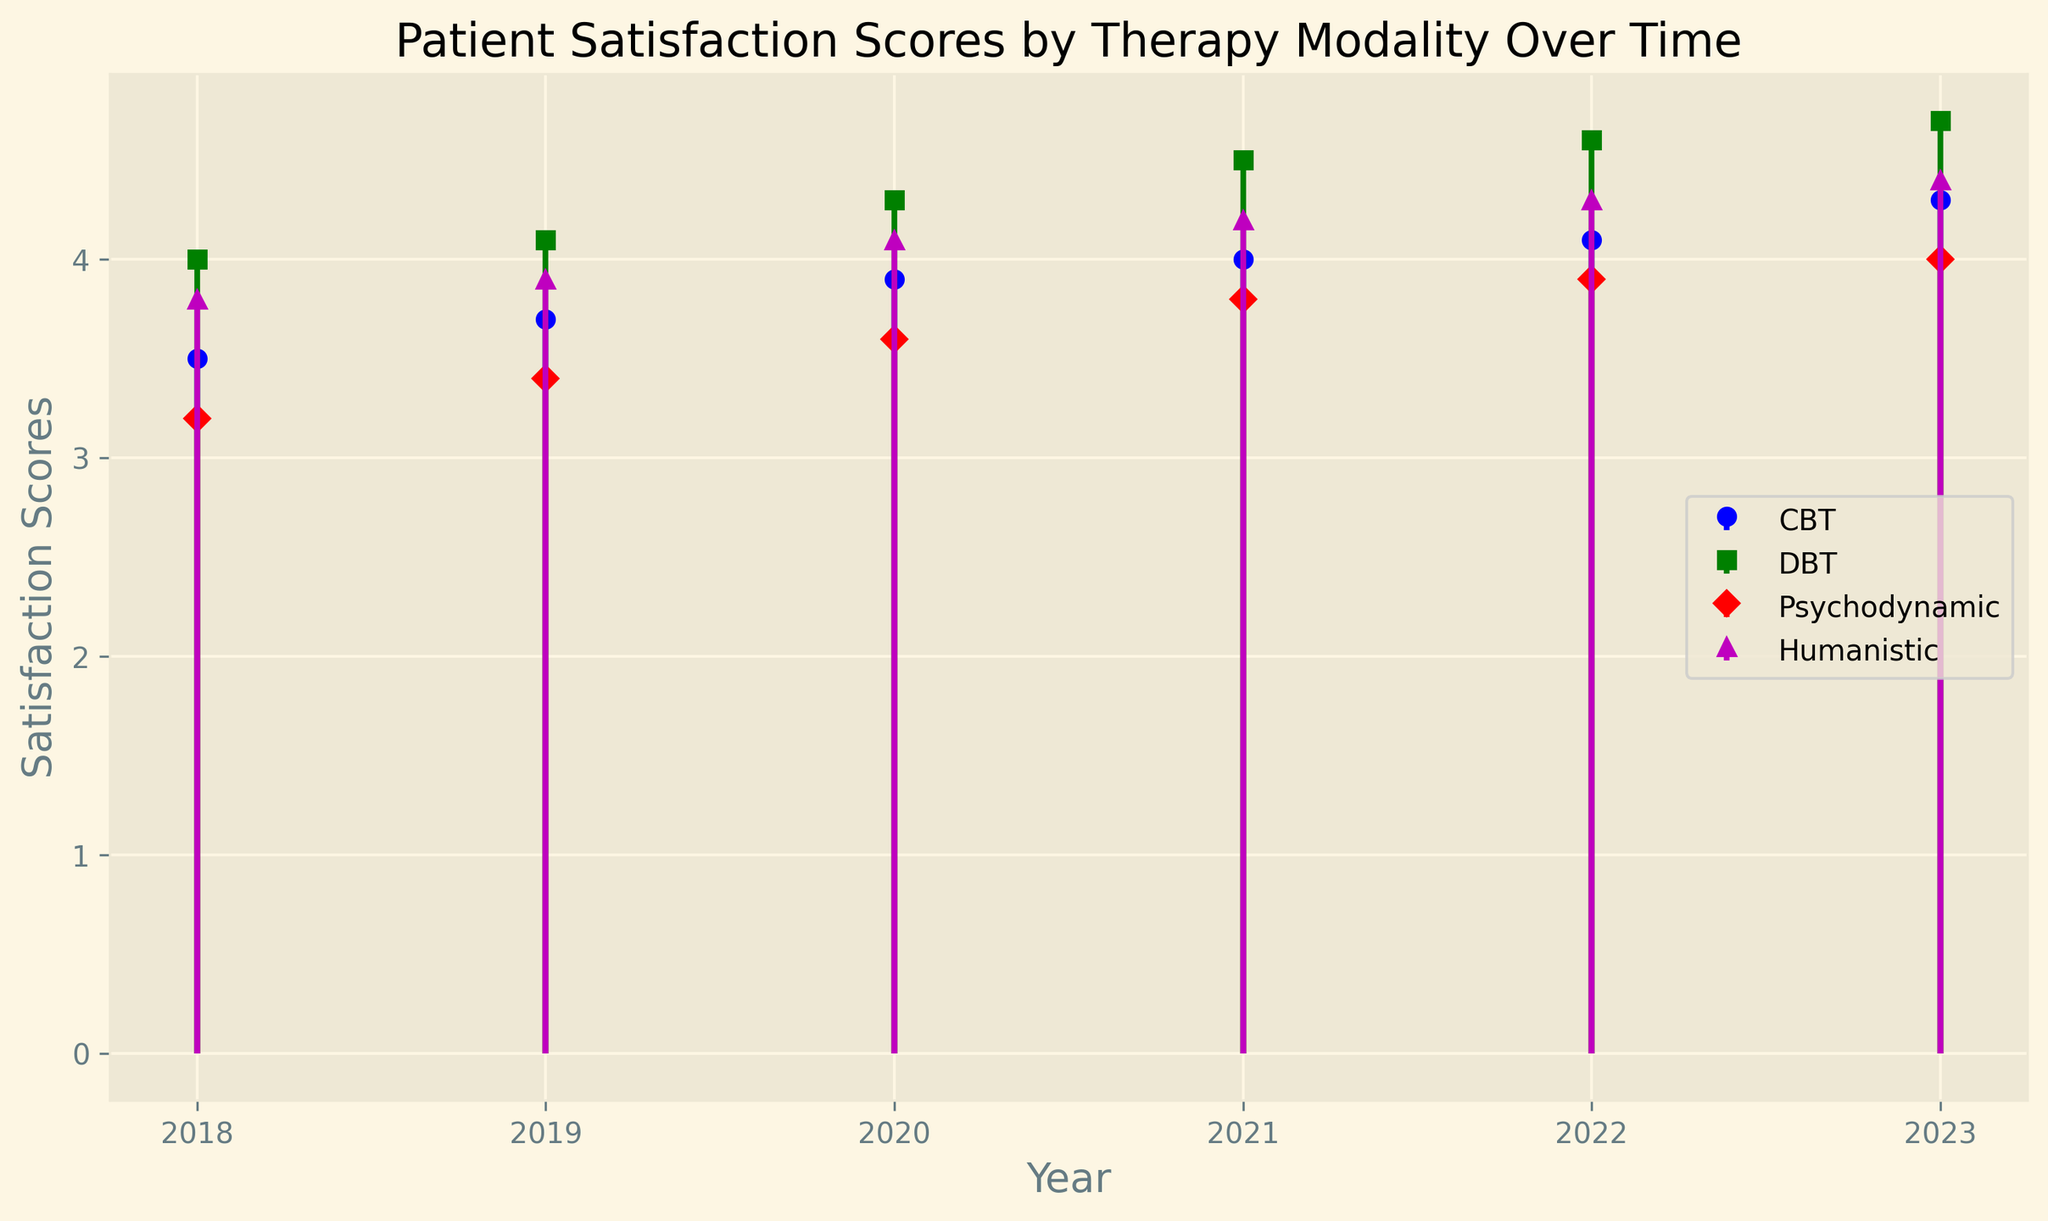What's the highest satisfaction score for CBT and in which year was it achieved? Look at the stem for CBT, identify the highest point, which is 4.3 in 2023.
Answer: 4.3 in 2023 How did the satisfaction score for Humanistic therapy change from 2018 to 2023? Compare the satisfaction score for Humanistic therapy in 2018 (3.8) and 2023 (4.4). Calculate the difference which is 4.4 - 3.8 = 0.6.
Answer: Increased by 0.6 Which therapy modality showed the greatest increase in satisfaction scores from 2018 to 2023? Calculate the increase for each modality: CBT (4.3 - 3.5 = 0.8), DBT (4.7 - 4.0 = 0.7), Psychodynamic (4.0 - 3.2 = 0.8), Humanistic (4.4 - 3.8 = 0.6). The greatest increase is 0.8 for CBT and Psychodynamic.
Answer: CBT and Psychodynamic In which year did Psychodynamic therapy have a score higher than 3.5 but lower than 4.0? Check the scores for Psychodynamic therapy: 2018 (3.2), 2019 (3.4), 2020 (3.6), 2021 (3.8), 2022 (3.9), 2023 (4.0). The years meeting the criteria are 2020, 2021, and 2022.
Answer: 2020, 2021, and 2022 Which therapy modality had the lowest satisfaction score in 2020? Look at the scores for 2020 in all modalities: CBT (3.9), DBT (4.3), Psychodynamic (3.6), Humanistic (4.1). Psychodynamic therapy had the lowest score of 3.6.
Answer: Psychodynamic By how much did the satisfaction score for DBT increase from 2019 to 2021? Compare the scores: 2019 (4.1), 2021 (4.5). The difference is 4.5 - 4.1 = 0.4.
Answer: 0.4 What's the average satisfaction score of all therapy modalities in 2022? Average the scores for 2022: (4.1 + 4.6 + 3.9 + 4.3)/4 = 4.225.
Answer: 4.225 Which modality has had a consistent yearly increase in satisfaction scores from 2018 to 2023? Check the scores year-by-year for all modalities: CBT (3.5, 3.7, 3.9, 4.0, 4.1, 4.3), DBT (4.0, 4.1, 4.3, 4.5, 4.6, 4.7), Psychodynamic (3.2, 3.4, 3.6, 3.8, 3.9, 4.0), Humanistic (3.8, 3.9, 4.1, 4.2, 4.3, 4.4). All modalities showed a consistent yearly increase.
Answer: All modalities Among all the therapy modalities, which one has the most visually prominent marker in the stem plot and what is the color of this marker? Identify the modality with the largest marker, looking for size and shape: DBT is marked with larger squares and colored green, making it most visually prominent.
Answer: DBT, green 